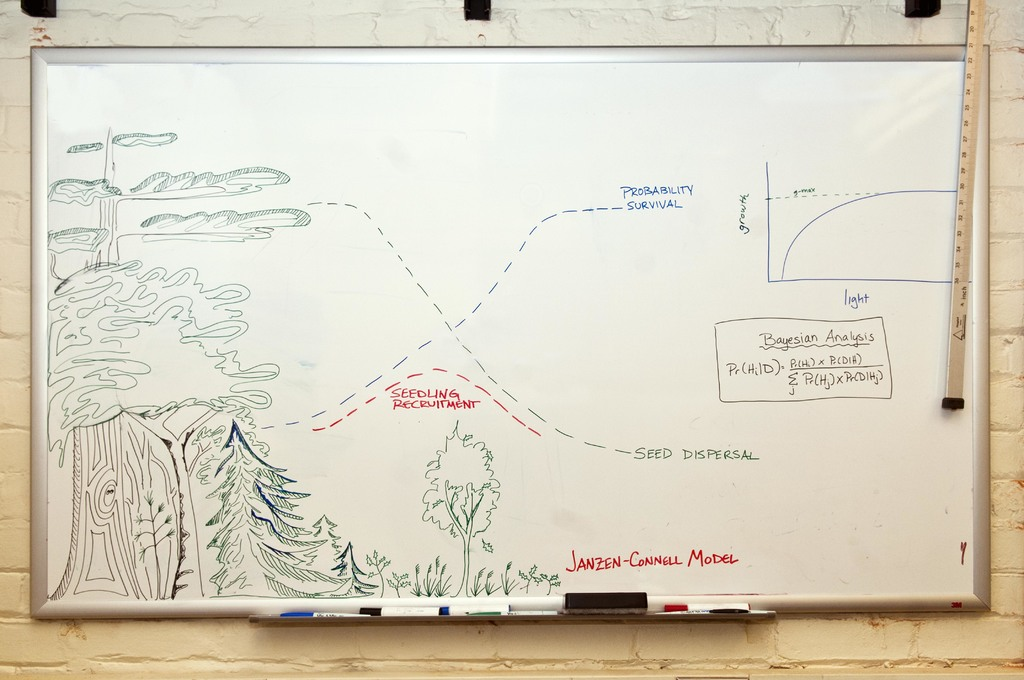What's happening in the scene? The image portrays a whiteboard explaining the Janzen-Connell hypothesis in ecology, elucidated via a detailed diagram and annotations. The centerpiece is a diagram showing a tree with seeds dispersing around it to various distances, illustrating the survival and growth probabilities of seedlings based on their dispersal. This diagram ties directly to the Janzen-Connell model's discussion on how distance from parent trees influences seed fate and plant diversity. Accompanying the diagram, there's a graph depicting the probability of seedling survival as it correlates to distance, highlighting key ecological insights. Additional notes include a Bayesian analysis formula, providing a scientific method to approach the hypothesis's statistical aspects. This image serves as an educational tool, cleverly integrating illustrations with scientific principles to explain how plant species' survival strategies impact ecological diversity. 